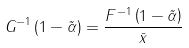Convert formula to latex. <formula><loc_0><loc_0><loc_500><loc_500>G ^ { - 1 } \left ( 1 - \tilde { \alpha } \right ) & = \frac { F ^ { - 1 } \left ( 1 - \tilde { \alpha } \right ) } { \bar { x } }</formula> 